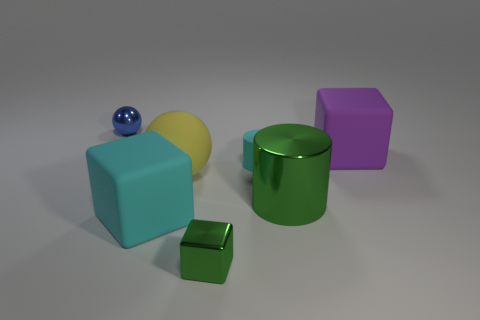Is there a big green cylinder made of the same material as the cyan cylinder?
Give a very brief answer. No. Are there the same number of small balls that are to the left of the small green thing and big yellow objects on the left side of the cyan block?
Offer a very short reply. No. What size is the cyan thing to the right of the small green thing?
Your response must be concise. Small. There is a tiny thing left of the big matte block in front of the purple block; what is it made of?
Your response must be concise. Metal. What number of rubber objects are to the left of the small thing to the left of the cyan thing that is on the left side of the tiny green block?
Give a very brief answer. 0. Is the large cube on the left side of the big purple matte thing made of the same material as the cyan thing behind the large ball?
Keep it short and to the point. Yes. What is the material of the thing that is the same color as the tiny cube?
Your answer should be very brief. Metal. How many small green things have the same shape as the blue metallic thing?
Your answer should be very brief. 0. Is the number of metallic objects that are in front of the small cyan rubber cylinder greater than the number of large cyan matte objects?
Ensure brevity in your answer.  Yes. There is a cyan matte thing that is behind the large matte block in front of the big rubber thing that is right of the cyan matte cylinder; what shape is it?
Give a very brief answer. Cylinder. 